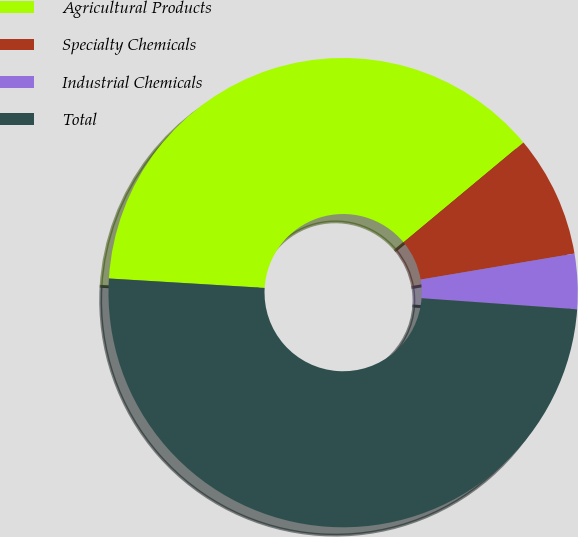Convert chart to OTSL. <chart><loc_0><loc_0><loc_500><loc_500><pie_chart><fcel>Agricultural Products<fcel>Specialty Chemicals<fcel>Industrial Chemicals<fcel>Total<nl><fcel>37.99%<fcel>8.39%<fcel>3.79%<fcel>49.83%<nl></chart> 